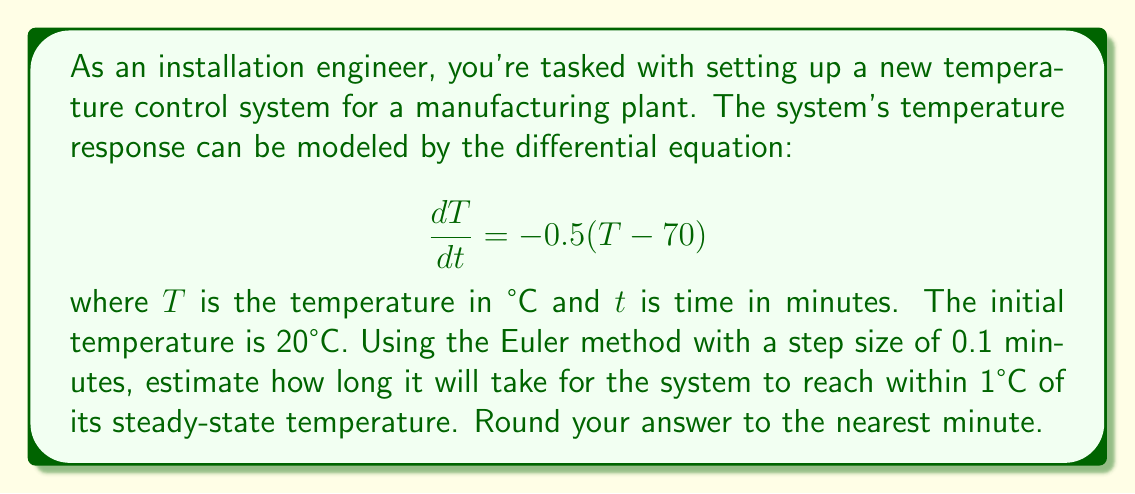What is the answer to this math problem? 1. First, identify the steady-state temperature:
   At steady-state, $\frac{dT}{dt} = 0$, so:
   $0 = -0.5(T_{ss} - 70)$
   $T_{ss} = 70°C$

2. We need to find when $|T - 70| < 1°C$

3. Set up the Euler method:
   $T_{n+1} = T_n + h \cdot f(T_n)$
   where $h = 0.1$ and $f(T) = -0.5(T - 70)$

4. Implement the method:
   $T_0 = 20$
   $T_1 = 20 + 0.1 \cdot (-0.5(20 - 70)) = 22.5$
   $T_2 = 22.5 + 0.1 \cdot (-0.5(22.5 - 70)) = 24.875$
   ...

5. Continue until $|T_n - 70| < 1$

6. After 46 steps:
   $T_{46} = 68.9916$

7. Convert steps to time:
   Time = 46 * 0.1 = 4.6 minutes

8. Round to the nearest minute: 5 minutes
Answer: 5 minutes 